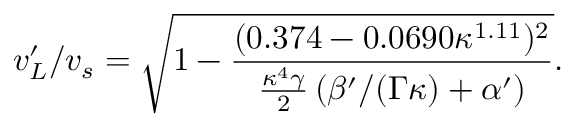Convert formula to latex. <formula><loc_0><loc_0><loc_500><loc_500>{ v _ { L } ^ { \prime } } / { v _ { s } } = \sqrt { 1 - \frac { ( 0 . 3 7 4 - 0 . 0 6 9 0 \kappa ^ { 1 . 1 1 } ) ^ { 2 } } { \frac { \kappa ^ { 4 } \gamma } { 2 } \left ( \beta ^ { \prime } / ( \Gamma \kappa ) + \alpha ^ { \prime } \right ) } } .</formula> 